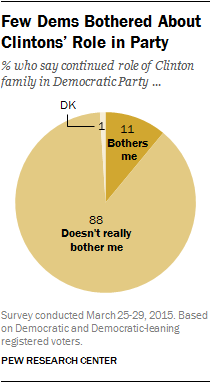Outline some significant characteristics in this image. The value of the DK segment ranges from 1 to 1. The ratio of the two largest segments in the comparison of A to B is 0.047222222... 